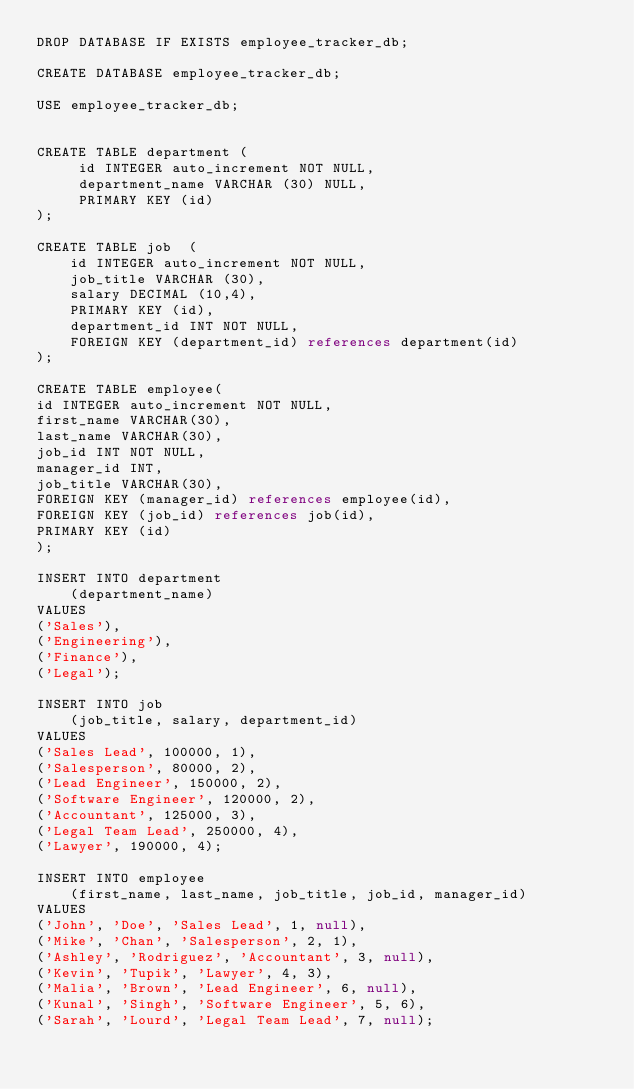<code> <loc_0><loc_0><loc_500><loc_500><_SQL_>DROP DATABASE IF EXISTS employee_tracker_db;

CREATE DATABASE employee_tracker_db;

USE employee_tracker_db;


CREATE TABLE department (
     id INTEGER auto_increment NOT NULL,
     department_name VARCHAR (30) NULL,
     PRIMARY KEY (id)
);

CREATE TABLE job  (
    id INTEGER auto_increment NOT NULL,
    job_title VARCHAR (30),
    salary DECIMAL (10,4),
    PRIMARY KEY (id),
    department_id INT NOT NULL,
    FOREIGN KEY (department_id) references department(id)
);

CREATE TABLE employee(
id INTEGER auto_increment NOT NULL, 
first_name VARCHAR(30), 
last_name VARCHAR(30),
job_id INT NOT NULL, 
manager_id INT,
job_title VARCHAR(30), 
FOREIGN KEY (manager_id) references employee(id),
FOREIGN KEY (job_id) references job(id),
PRIMARY KEY (id)
);

INSERT INTO department 
    (department_name)
VALUES
('Sales'),
('Engineering'),
('Finance'),
('Legal');

INSERT INTO job
    (job_title, salary, department_id)
VALUES 
('Sales Lead', 100000, 1),
('Salesperson', 80000, 2),
('Lead Engineer', 150000, 2),
('Software Engineer', 120000, 2),
('Accountant', 125000, 3),
('Legal Team Lead', 250000, 4),
('Lawyer', 190000, 4);

INSERT INTO employee 
    (first_name, last_name, job_title, job_id, manager_id)
VALUES
('John', 'Doe', 'Sales Lead', 1, null),
('Mike', 'Chan', 'Salesperson', 2, 1),
('Ashley', 'Rodriguez', 'Accountant', 3, null),
('Kevin', 'Tupik', 'Lawyer', 4, 3),
('Malia', 'Brown', 'Lead Engineer', 6, null),
('Kunal', 'Singh', 'Software Engineer', 5, 6),
('Sarah', 'Lourd', 'Legal Team Lead', 7, null);
</code> 